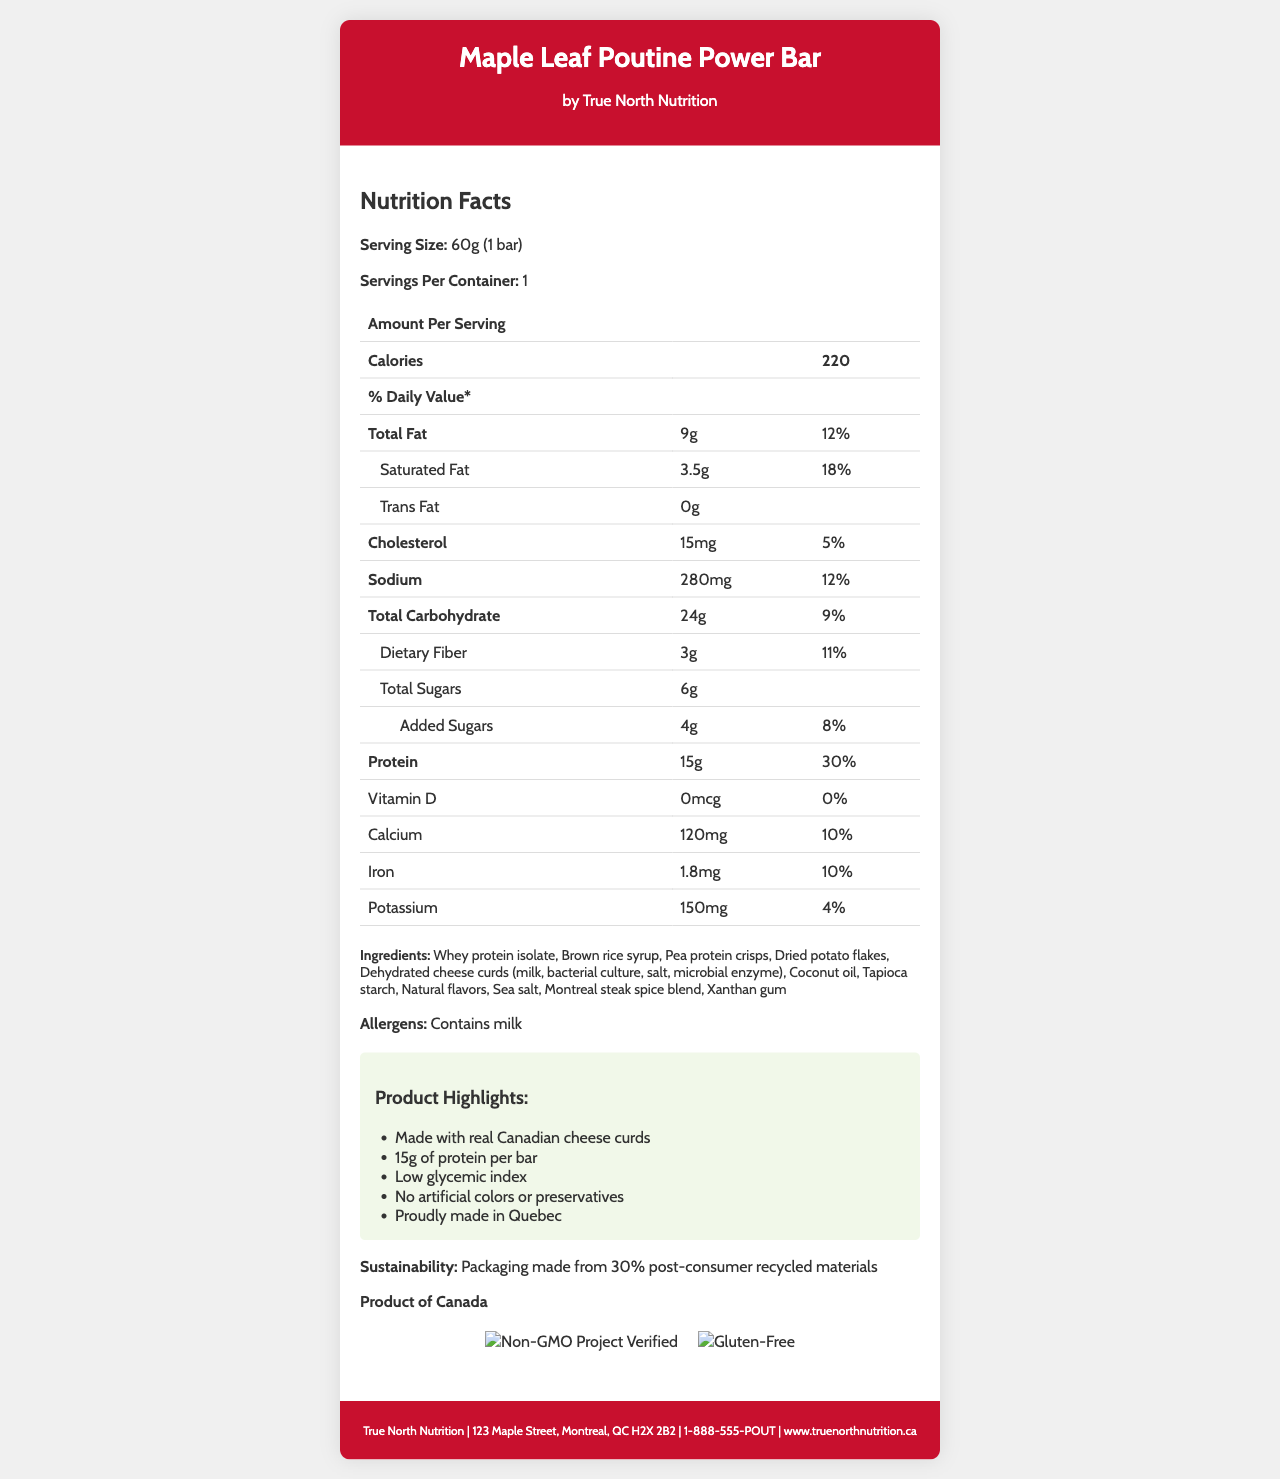what is the serving size of the Maple Leaf Poutine Power Bar? The serving size is listed directly under the Nutrition Facts header as "Serving Size: 60g (1 bar)".
Answer: 60g (1 bar) how many calories does one serving contain? The document states "Calories 220" in the Amount Per Serving section.
Answer: 220 how much protein is in one bar? The Protein amount is listed as "15g" in the Amount Per Serving section.
Answer: 15g what are the main ingredients of the poutine-flavored protein bar? The ingredients are listed under the Ingredients header.
Answer: Whey protein isolate, Brown rice syrup, Pea protein crisps, Dried potato flakes, Dehydrated cheese curds, Coconut oil, Tapioca starch, Natural flavors, Sea salt, Montreal steak spice blend, Xanthan gum is the product gluten-free? The document shows a certification crest for "Gluten-Free."
Answer: Yes how much added sugar does the bar contain? The section under Total Sugars shows "Added Sugars: 4g".
Answer: 4g how many mg of sodium does the bar have? A. 120mg B. 280mg C. 150mg D. 100mg The document lists Sodium as "280mg" in the Amount Per Serving section.
Answer: B. 280mg what percentage of the daily value of calcium does one bar provide? A. 5% B. 9% C. 10% D. 15% The document lists Calcium as "10%" in the % Daily Value column.
Answer: C. 10% is vitamin D present in the bar? The document lists Vitamin D as "0mcg" with a daily value of "0%".
Answer: No what certifications does the bar have? The certifications are listed directly in the document including images of the certification crests.
Answer: Non-GMO Project Verified, Gluten-Free does the product contain peanuts? The document does not provide information about whether the product contains peanuts or not.
Answer: Cannot be determined what is the total fat content in each bar? The document lists Total Fat as "9g" in the Amount Per Serving section.
Answer: 9g is there any trans fat in one serving of the bar? The document lists Trans Fat as "0g" in the Amount Per Serving section.
Answer: No how much dietary fiber is in the bar? The document lists Dietary Fiber as "3g" in the Amount Per Serving section.
Answer: 3g which of the following marketing claims is made about the product? A. Contains artificial colors B. Low in sodium C. Made with real Canadian cheese curds D. High in saturated fat The document lists the marketing claim "Made with real Canadian cheese curds" under Product Highlights.
Answer: C. Made with real Canadian cheese curds summarize the main characteristics of this nutrition bar. The summary integrates the key details like nutritional content, ingredients, certifications, marketing claims, and additional product highlights demonstrating the authenticity and quality of the bar.
Answer: The Maple Leaf Poutine Power Bar by True North Nutrition offers 220 calories per 60g bar, includes 15g of protein, and features unique ingredients like dehydrated cheese curds, reflecting Canadian flavors. The bar is non-GMO, gluten-free, and carries several marketing claims such as being made with real Canadian cheese curds and low glycemic index. It is proudly made in Quebec, with packaging partly from recycled materials. 